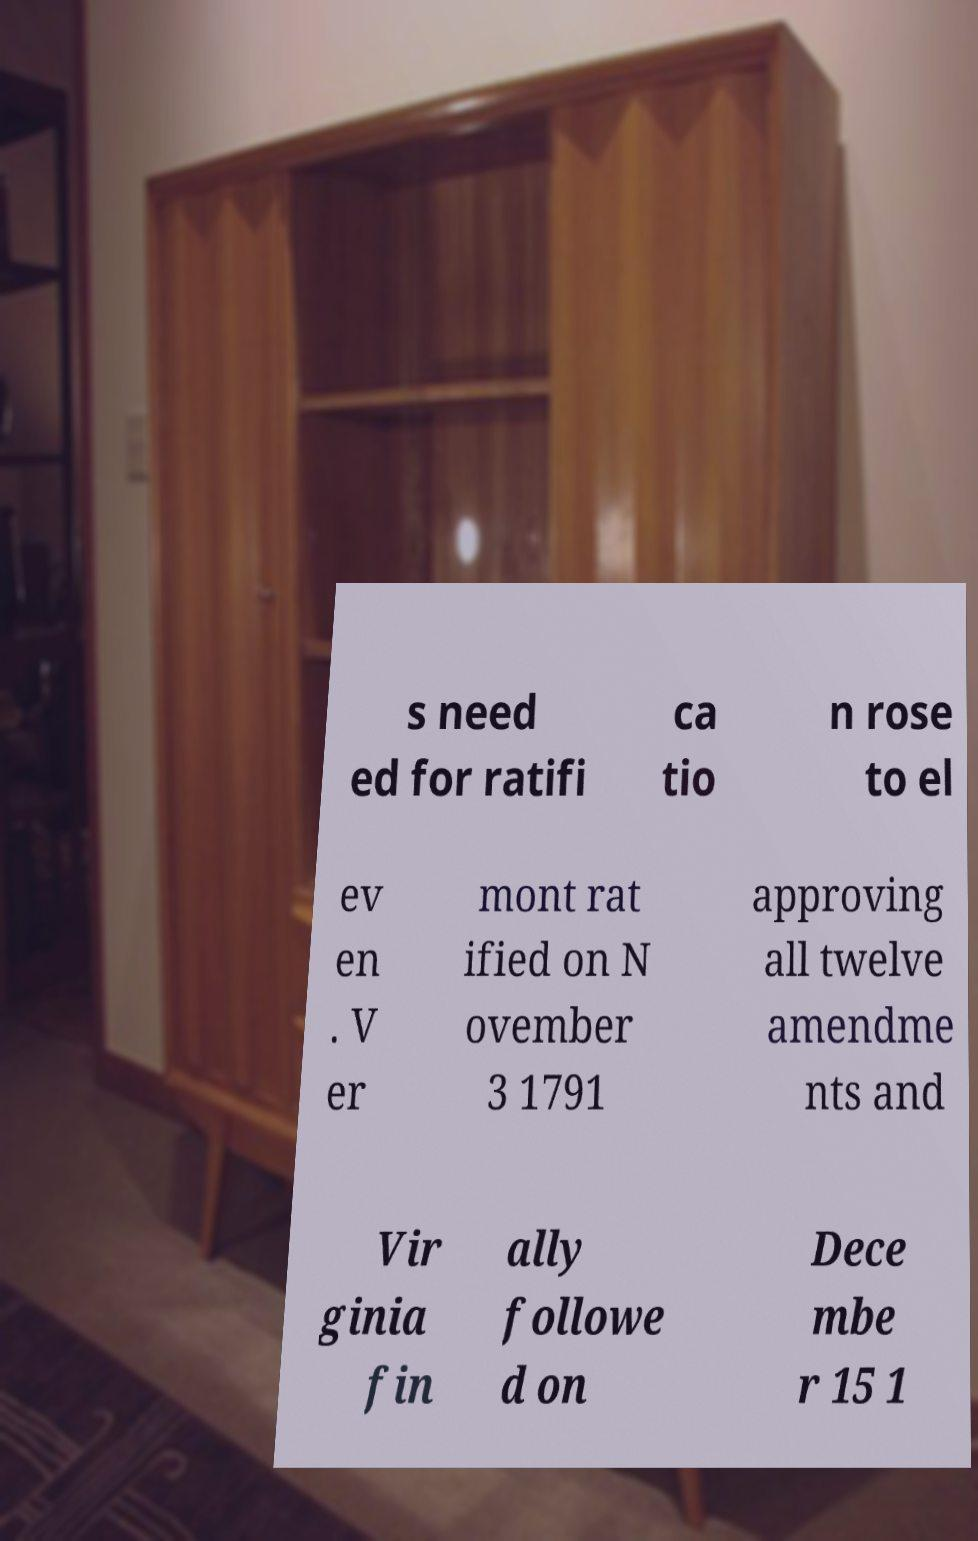Please read and relay the text visible in this image. What does it say? s need ed for ratifi ca tio n rose to el ev en . V er mont rat ified on N ovember 3 1791 approving all twelve amendme nts and Vir ginia fin ally followe d on Dece mbe r 15 1 